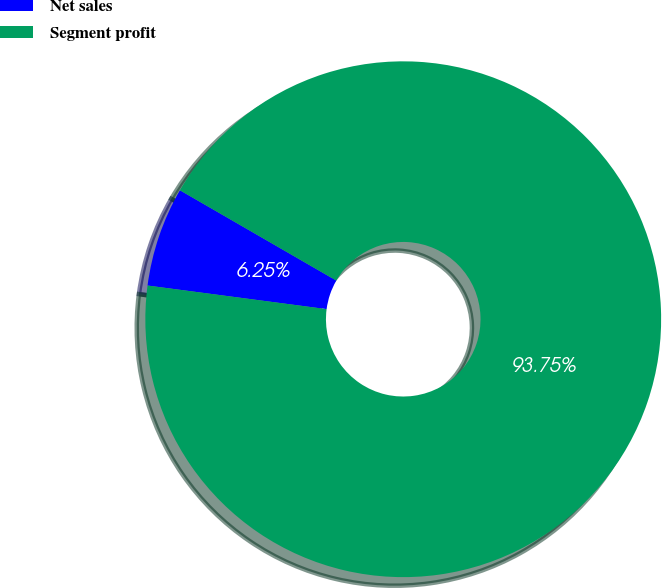Convert chart to OTSL. <chart><loc_0><loc_0><loc_500><loc_500><pie_chart><fcel>Net sales<fcel>Segment profit<nl><fcel>6.25%<fcel>93.75%<nl></chart> 